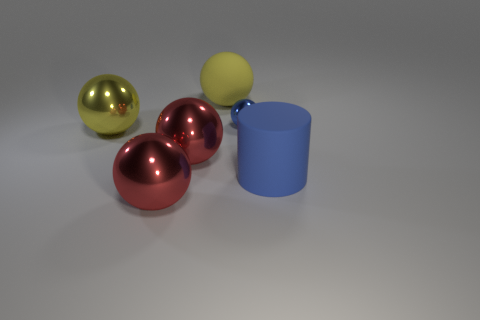Are there any large objects that have the same color as the big matte sphere?
Your answer should be very brief. Yes. Do the yellow shiny thing and the yellow thing behind the tiny object have the same size?
Offer a terse response. Yes. How many big yellow shiny things are left of the matte object to the right of the large object that is behind the big yellow shiny object?
Your answer should be very brief. 1. What number of large yellow rubber objects are in front of the big yellow matte sphere?
Provide a succinct answer. 0. What is the color of the rubber object behind the big rubber thing that is in front of the tiny blue ball?
Make the answer very short. Yellow. What number of other objects are the same material as the blue cylinder?
Your answer should be compact. 1. Is the number of small metal spheres to the right of the blue rubber thing the same as the number of red metal spheres?
Offer a terse response. No. What is the material of the blue object that is left of the big rubber thing to the right of the rubber thing that is behind the big cylinder?
Offer a very short reply. Metal. There is a matte object that is to the left of the small blue metal thing; what color is it?
Your response must be concise. Yellow. Is there any other thing that has the same shape as the blue rubber object?
Your response must be concise. No. 